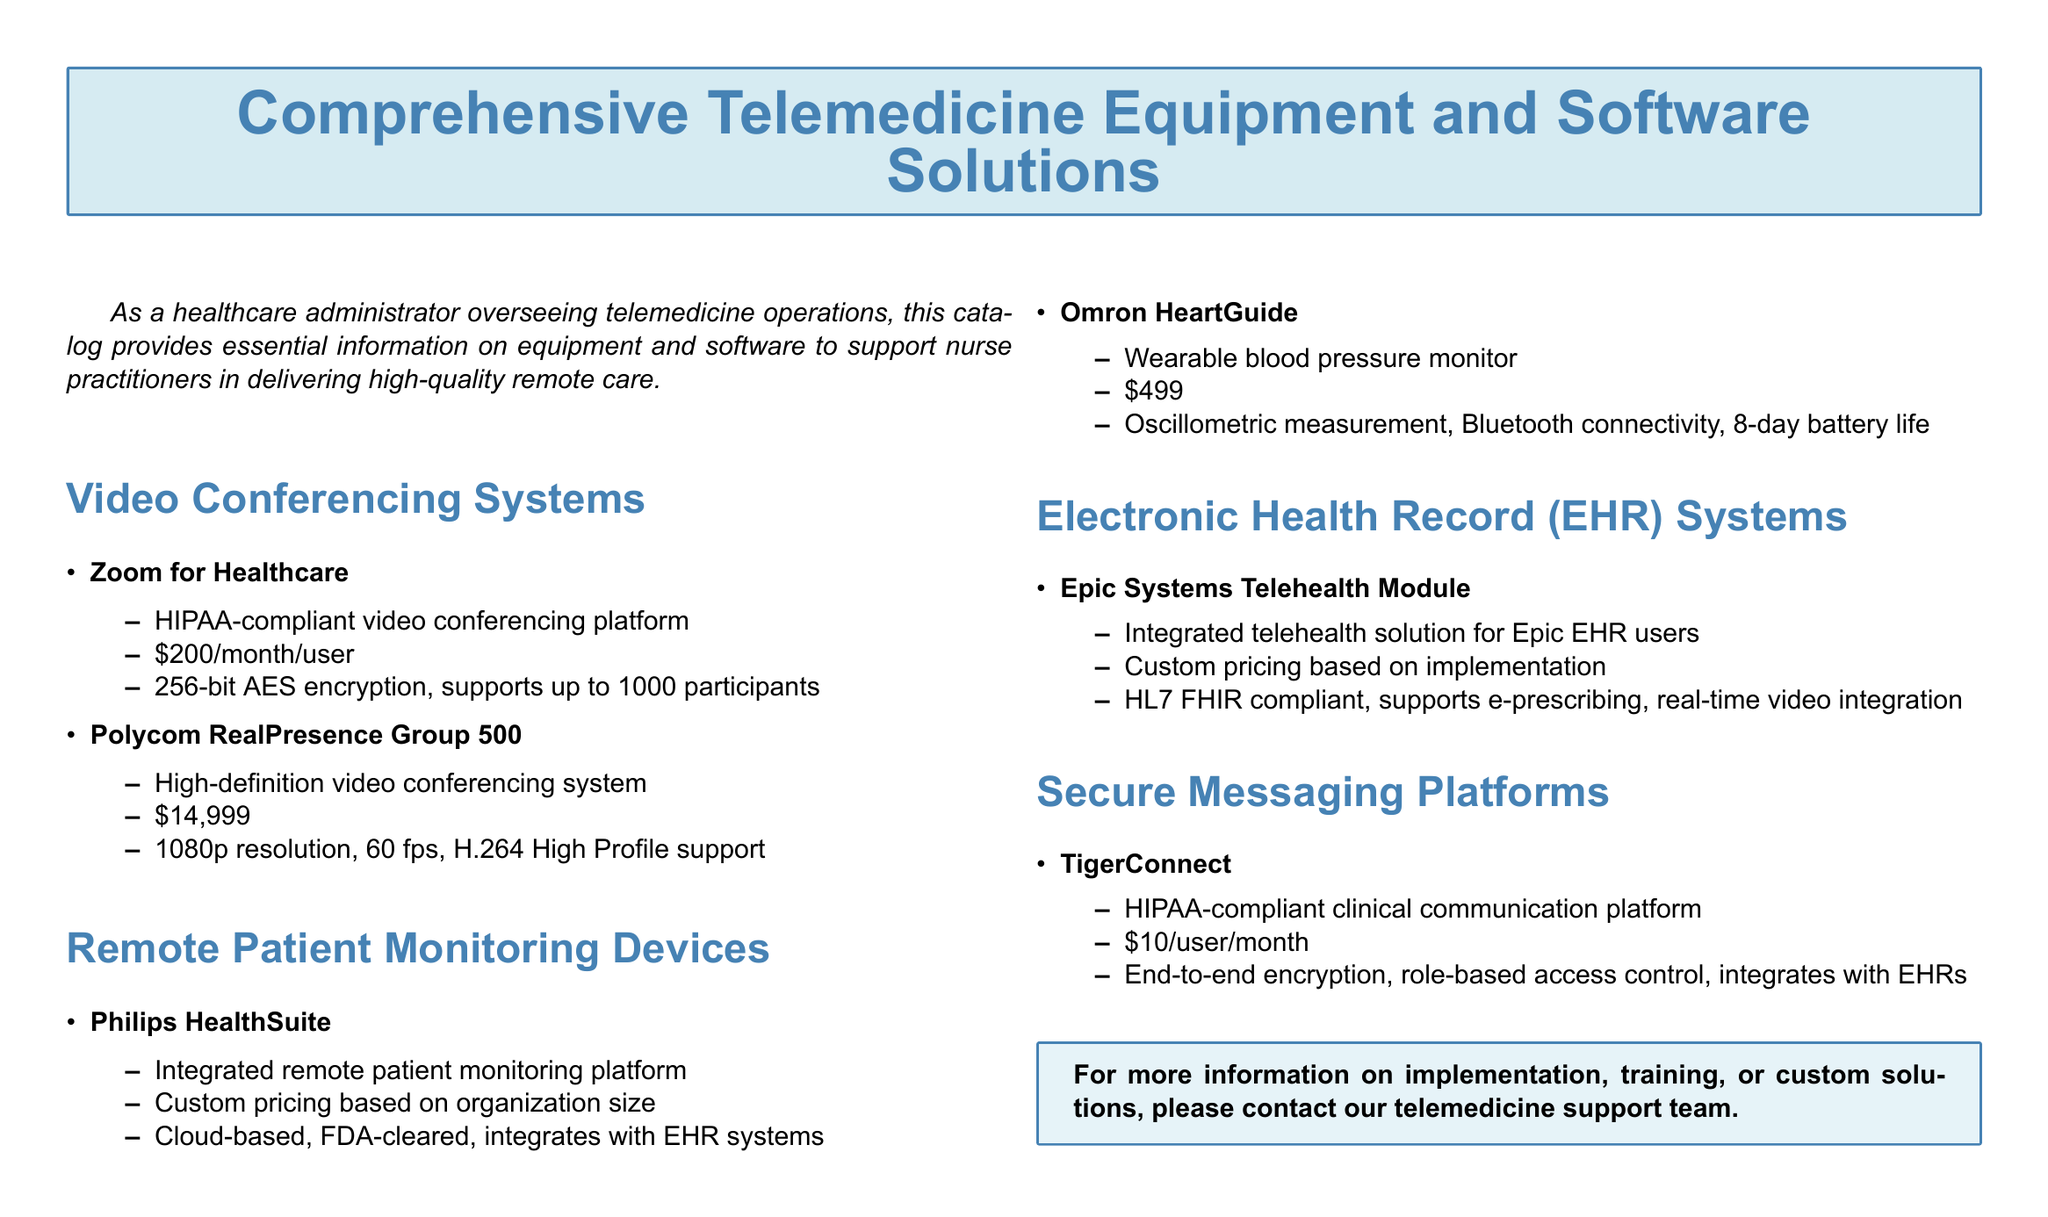what is the price of Zoom for Healthcare? The price is listed directly in the document under the video conferencing systems section.
Answer: $200/month/user what is the resolution of Polycom RealPresence Group 500? The resolution is detailed in the product specifications for the Polycom RealPresence Group 500.
Answer: 1080p what type of device is Omron HeartGuide? The type of device is specified in the remote patient monitoring devices section.
Answer: Wearable blood pressure monitor how much does TigerConnect cost per user per month? The cost is mentioned under the secure messaging platforms section of the document.
Answer: $10/user/month what compliance does Epic Systems Telehealth Module support? The compliance information is provided for the Epic Systems Telehealth Module under electronic health record systems.
Answer: HL7 FHIR which video conferencing system supports up to 1000 participants? The supported participant capacity is listed under the specifications for video conferencing systems.
Answer: Zoom for Healthcare is Philips HealthSuite FDA-cleared? The clearance information is included in the description of Philips HealthSuite.
Answer: Yes what type of communication platform is TigerConnect? The type of platform is specified in the secure messaging platforms section.
Answer: Clinical communication platform what kind of battery life does the Omron HeartGuide have? The battery life is stated in the device specifications in the remote patient monitoring section.
Answer: 8-day battery life 